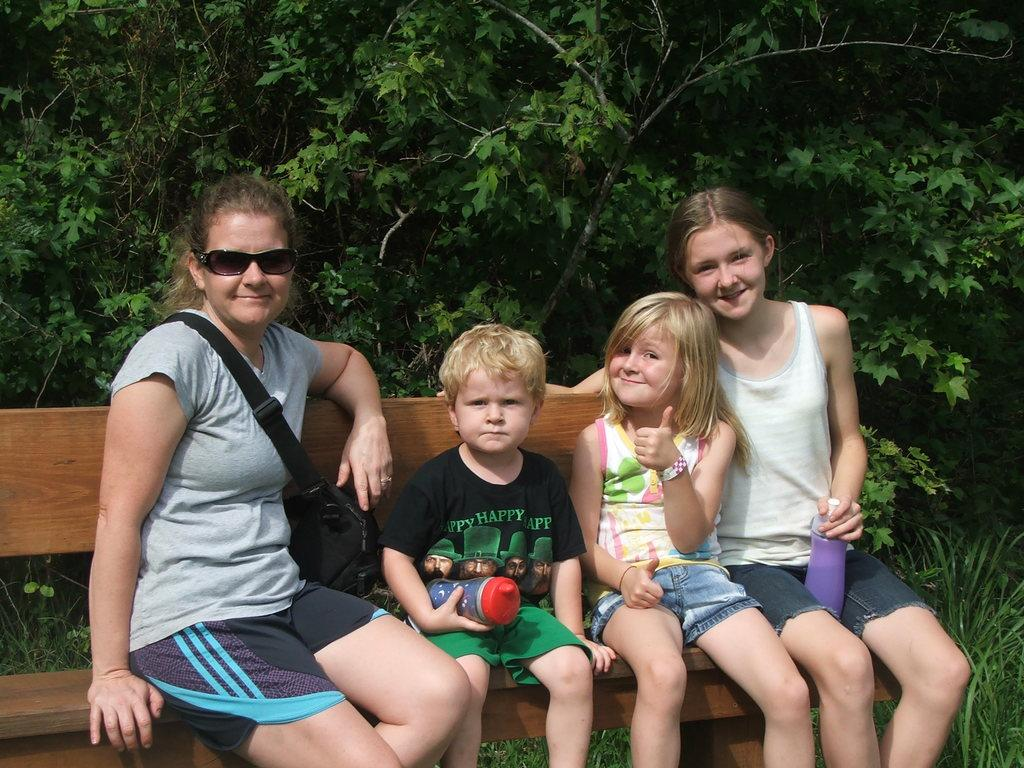What can be seen in the background of the image? There are trees in the background of the image. What are the people in the image doing? The people are sitting on a bench in the image. Where is the kettle located in the image? There is no kettle present in the image. What type of store can be seen in the background of the image? There is no store visible in the background of the image; only trees are present. 